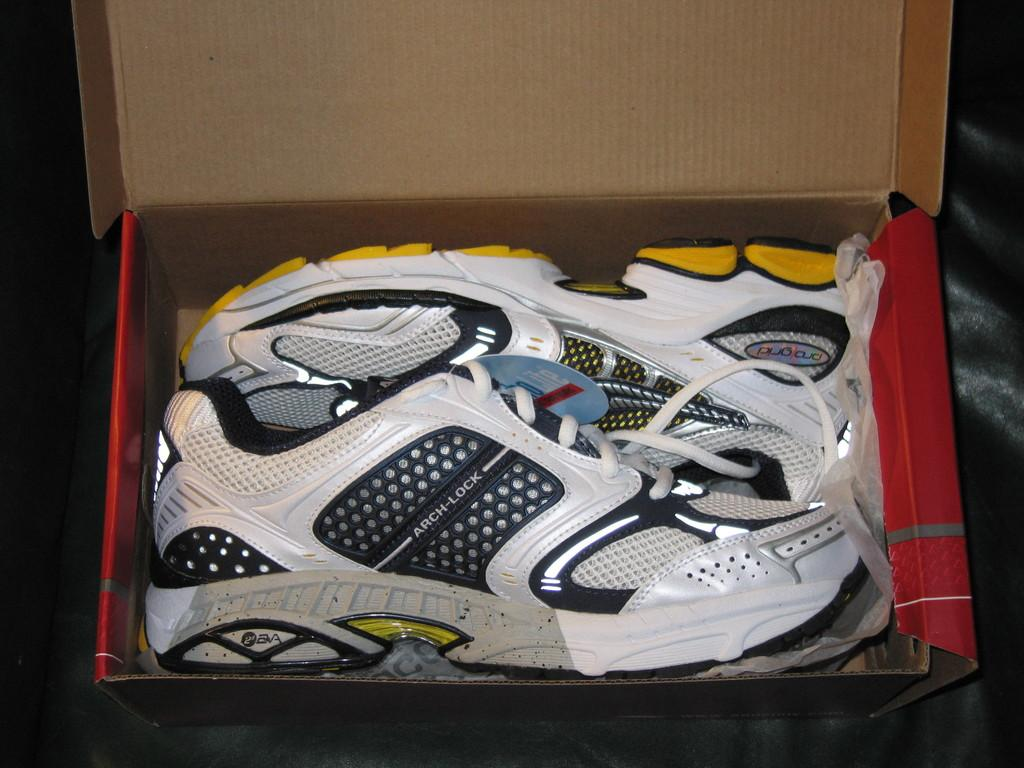What type of furniture is in the image? There is a couch in the image. What is placed on the couch? There are shoes in a box on the couch. What type of education is being taught on the couch in the image? There is no indication of any education being taught in the image; it only shows a couch with shoes in a box on it. 